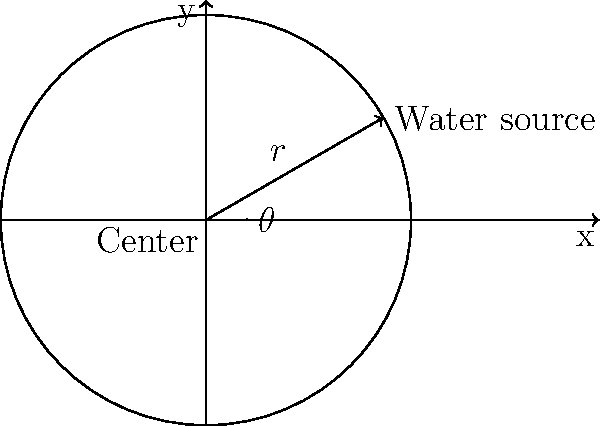In a circular refugee camp layout, a water source is located at a distance of 5 units from the center at an angle of 30 degrees from the positive x-axis. Using polar coordinates $(r,\theta)$, what is the position of the water source? To determine the position of the water source using polar coordinates, we need to follow these steps:

1. Identify the given information:
   - Distance from the center (r) = 5 units
   - Angle from the positive x-axis (θ) = 30 degrees

2. Convert the angle from degrees to radians:
   $\theta = 30° \times \frac{\pi}{180°} = \frac{\pi}{6}$ radians

3. Express the position in polar coordinates:
   The polar coordinate form is $(r,\theta)$, where:
   $r = 5$ (given)
   $\theta = \frac{\pi}{6}$ (calculated in step 2)

4. Therefore, the position of the water source in polar coordinates is $(5,\frac{\pi}{6})$

This representation allows for efficient mapping of resources within the circular refugee camp layout, which is crucial for humanitarian aid planning and distribution.
Answer: $(5,\frac{\pi}{6})$ 